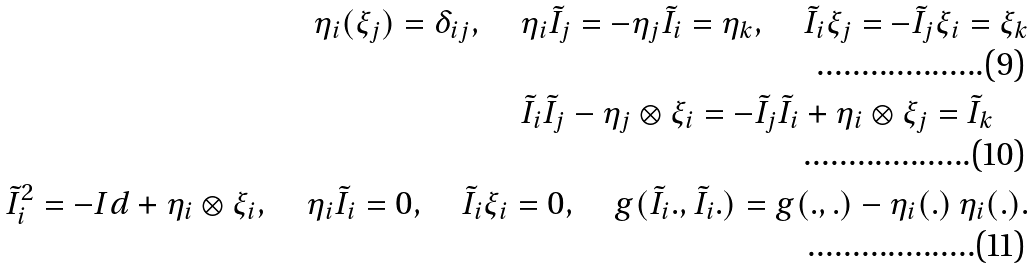Convert formula to latex. <formula><loc_0><loc_0><loc_500><loc_500>\eta _ { i } ( \xi _ { j } ) = \delta _ { i j } , \quad \eta _ { i } \tilde { I } _ { j } = - \eta _ { j } \tilde { I } _ { i } = \eta _ { k } , \quad \tilde { I } _ { i } \xi _ { j } = - \tilde { I } _ { j } \xi _ { i } = \xi _ { k } \\ \tilde { I } _ { i } \tilde { I } _ { j } - \eta _ { j } \otimes \xi _ { i } = - \tilde { I } _ { j } \tilde { I } _ { i } + \eta _ { i } \otimes \xi _ { j } = \tilde { I } _ { k } \quad \\ \tilde { I } _ { i } ^ { 2 } = - I d + \eta _ { i } \otimes \xi _ { i } , \quad \eta _ { i } \tilde { I } _ { i } = 0 , \quad \tilde { I } _ { i } \xi _ { i } = 0 , \quad g ( \tilde { I } _ { i } . , \tilde { I } _ { i } . ) = g ( . , . ) - \eta _ { i } ( . ) \, \eta _ { i } ( . ) .</formula> 